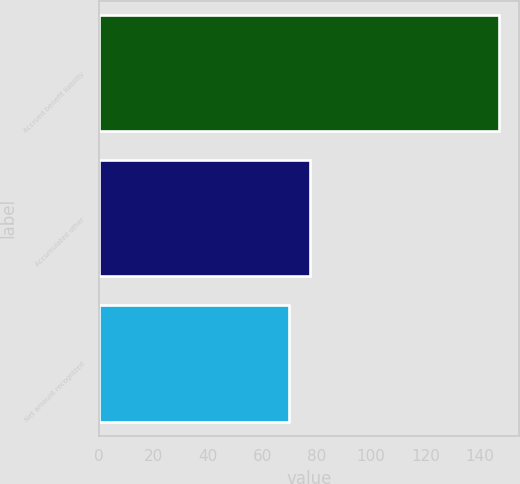Convert chart to OTSL. <chart><loc_0><loc_0><loc_500><loc_500><bar_chart><fcel>Accrued benefit liability<fcel>Accumulated other<fcel>Net amount recognized<nl><fcel>147<fcel>77.7<fcel>70<nl></chart> 